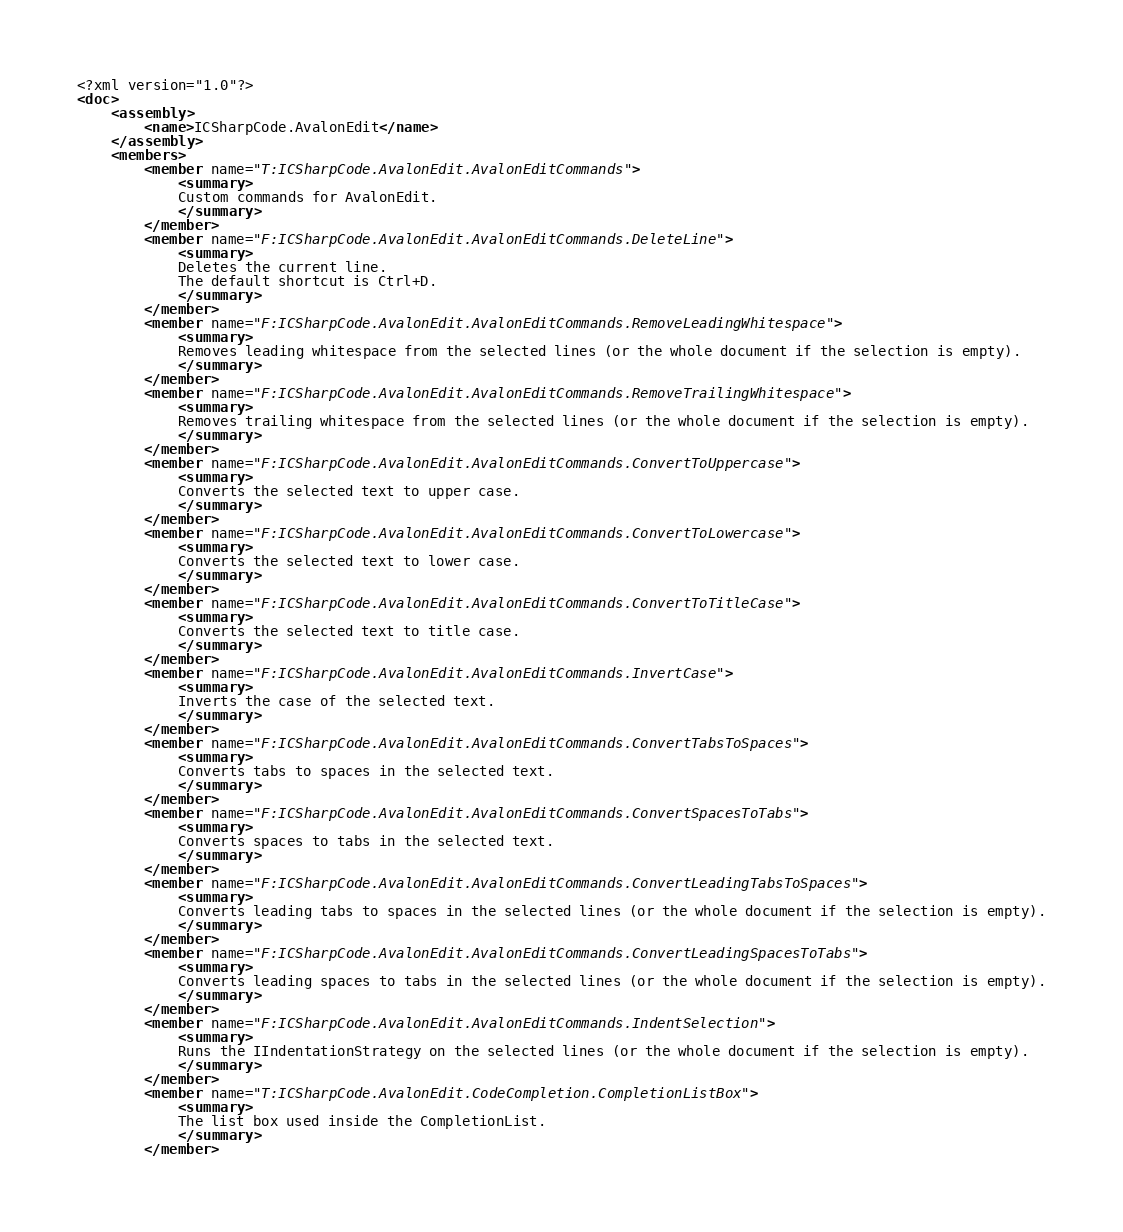<code> <loc_0><loc_0><loc_500><loc_500><_XML_><?xml version="1.0"?>
<doc>
    <assembly>
        <name>ICSharpCode.AvalonEdit</name>
    </assembly>
    <members>
        <member name="T:ICSharpCode.AvalonEdit.AvalonEditCommands">
            <summary>
            Custom commands for AvalonEdit.
            </summary>
        </member>
        <member name="F:ICSharpCode.AvalonEdit.AvalonEditCommands.DeleteLine">
            <summary>
            Deletes the current line.
            The default shortcut is Ctrl+D.
            </summary>
        </member>
        <member name="F:ICSharpCode.AvalonEdit.AvalonEditCommands.RemoveLeadingWhitespace">
            <summary>
            Removes leading whitespace from the selected lines (or the whole document if the selection is empty).
            </summary>
        </member>
        <member name="F:ICSharpCode.AvalonEdit.AvalonEditCommands.RemoveTrailingWhitespace">
            <summary>
            Removes trailing whitespace from the selected lines (or the whole document if the selection is empty).
            </summary>
        </member>
        <member name="F:ICSharpCode.AvalonEdit.AvalonEditCommands.ConvertToUppercase">
            <summary>
            Converts the selected text to upper case.
            </summary>
        </member>
        <member name="F:ICSharpCode.AvalonEdit.AvalonEditCommands.ConvertToLowercase">
            <summary>
            Converts the selected text to lower case.
            </summary>
        </member>
        <member name="F:ICSharpCode.AvalonEdit.AvalonEditCommands.ConvertToTitleCase">
            <summary>
            Converts the selected text to title case.
            </summary>
        </member>
        <member name="F:ICSharpCode.AvalonEdit.AvalonEditCommands.InvertCase">
            <summary>
            Inverts the case of the selected text.
            </summary>
        </member>
        <member name="F:ICSharpCode.AvalonEdit.AvalonEditCommands.ConvertTabsToSpaces">
            <summary>
            Converts tabs to spaces in the selected text.
            </summary>
        </member>
        <member name="F:ICSharpCode.AvalonEdit.AvalonEditCommands.ConvertSpacesToTabs">
            <summary>
            Converts spaces to tabs in the selected text.
            </summary>
        </member>
        <member name="F:ICSharpCode.AvalonEdit.AvalonEditCommands.ConvertLeadingTabsToSpaces">
            <summary>
            Converts leading tabs to spaces in the selected lines (or the whole document if the selection is empty).
            </summary>
        </member>
        <member name="F:ICSharpCode.AvalonEdit.AvalonEditCommands.ConvertLeadingSpacesToTabs">
            <summary>
            Converts leading spaces to tabs in the selected lines (or the whole document if the selection is empty).
            </summary>
        </member>
        <member name="F:ICSharpCode.AvalonEdit.AvalonEditCommands.IndentSelection">
            <summary>
            Runs the IIndentationStrategy on the selected lines (or the whole document if the selection is empty).
            </summary>
        </member>
        <member name="T:ICSharpCode.AvalonEdit.CodeCompletion.CompletionListBox">
            <summary>
            The list box used inside the CompletionList.
            </summary>
        </member></code> 